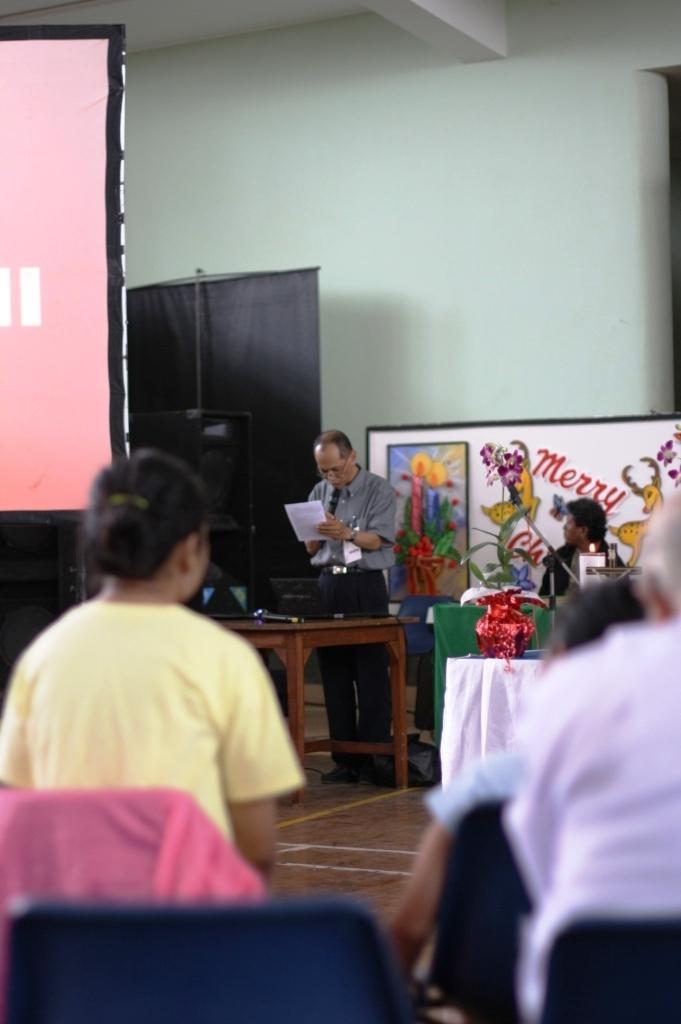How would you summarize this image in a sentence or two? This is screen,this person is standing and reading paper,this is table,this person is sitting on the chair and in background there is wall.. 